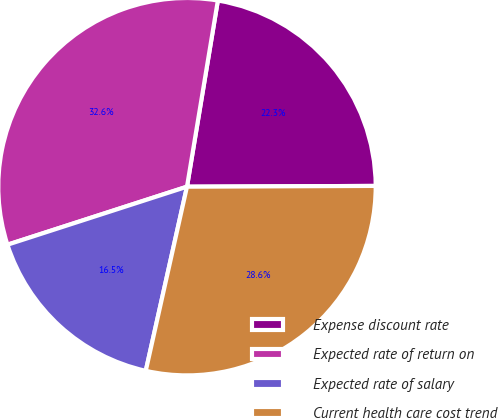Convert chart to OTSL. <chart><loc_0><loc_0><loc_500><loc_500><pie_chart><fcel>Expense discount rate<fcel>Expected rate of return on<fcel>Expected rate of salary<fcel>Current health care cost trend<nl><fcel>22.32%<fcel>32.59%<fcel>16.52%<fcel>28.57%<nl></chart> 